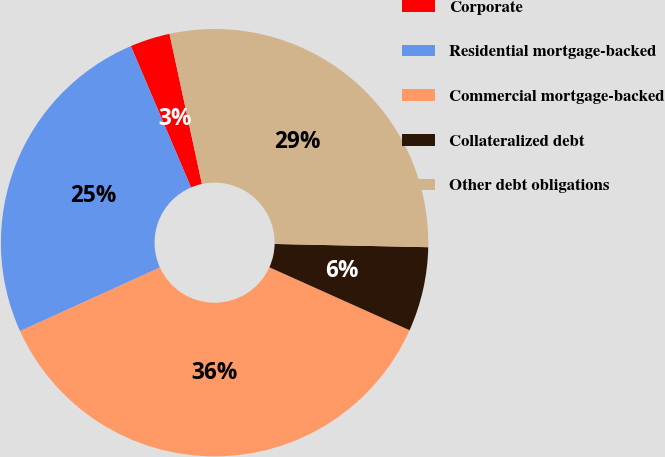Convert chart to OTSL. <chart><loc_0><loc_0><loc_500><loc_500><pie_chart><fcel>Corporate<fcel>Residential mortgage-backed<fcel>Commercial mortgage-backed<fcel>Collateralized debt<fcel>Other debt obligations<nl><fcel>3.03%<fcel>25.38%<fcel>36.49%<fcel>6.38%<fcel>28.72%<nl></chart> 